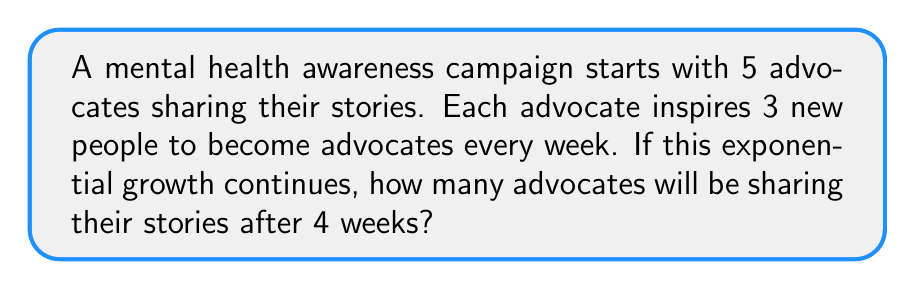Solve this math problem. Let's approach this step-by-step:

1) We start with 5 advocates.

2) Each week, the number of advocates triples. This means we multiply by 3 each week.

3) We can represent this growth over 4 weeks as:

   $5 \cdot 3^4$

4) Let's calculate this:
   
   $5 \cdot 3^4 = 5 \cdot 81$

5) $5 \cdot 81 = 405$

Therefore, after 4 weeks, there will be 405 advocates sharing their stories.

This exponential growth demonstrates how quickly awareness can spread when people share their experiences, potentially offering hope and inspiration to many others struggling with mental health issues.
Answer: 405 advocates 